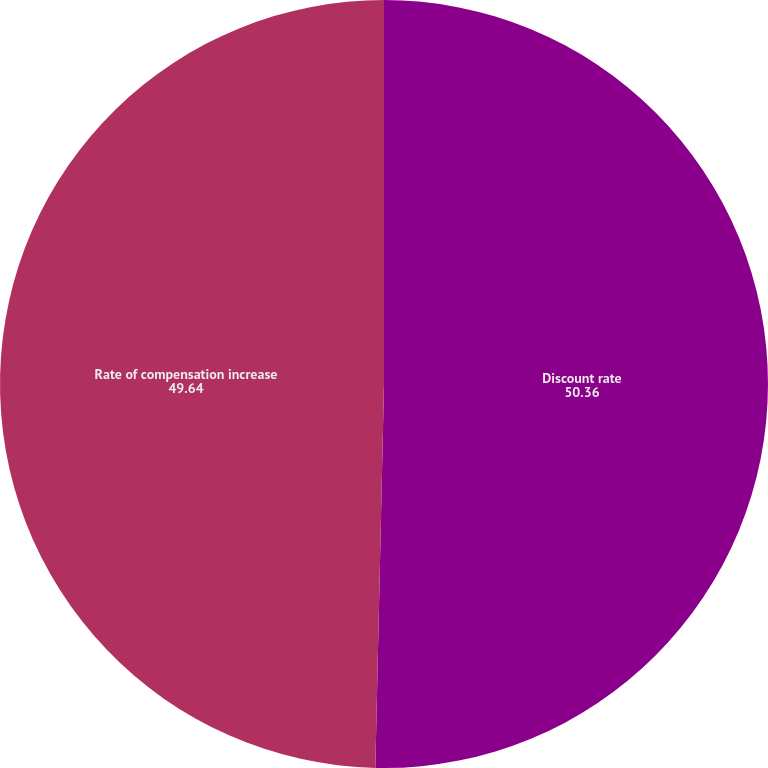Convert chart to OTSL. <chart><loc_0><loc_0><loc_500><loc_500><pie_chart><fcel>Discount rate<fcel>Rate of compensation increase<nl><fcel>50.36%<fcel>49.64%<nl></chart> 